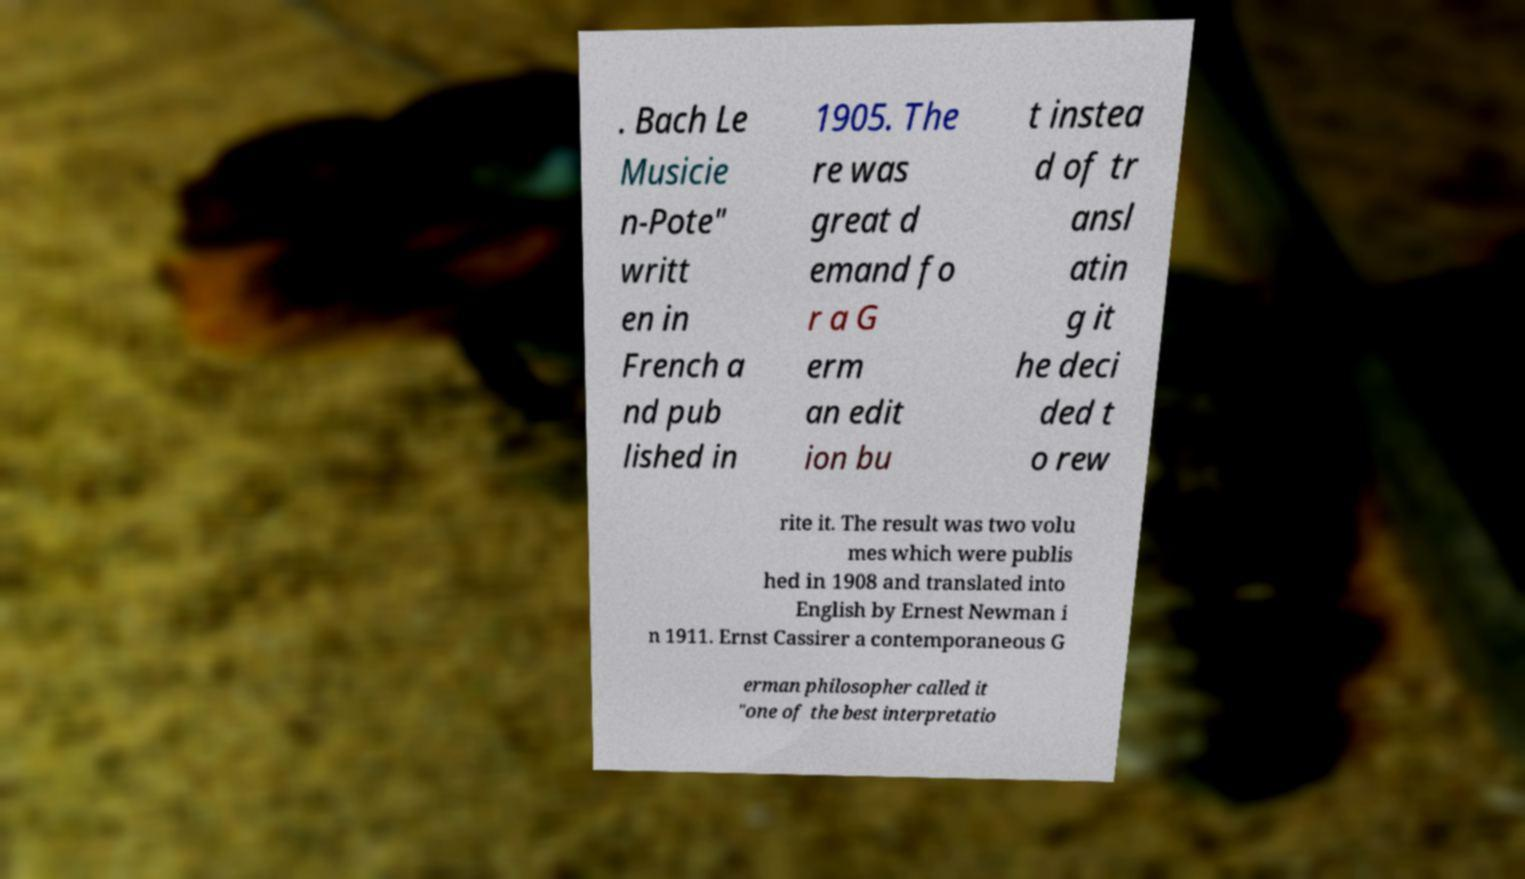There's text embedded in this image that I need extracted. Can you transcribe it verbatim? . Bach Le Musicie n-Pote" writt en in French a nd pub lished in 1905. The re was great d emand fo r a G erm an edit ion bu t instea d of tr ansl atin g it he deci ded t o rew rite it. The result was two volu mes which were publis hed in 1908 and translated into English by Ernest Newman i n 1911. Ernst Cassirer a contemporaneous G erman philosopher called it "one of the best interpretatio 